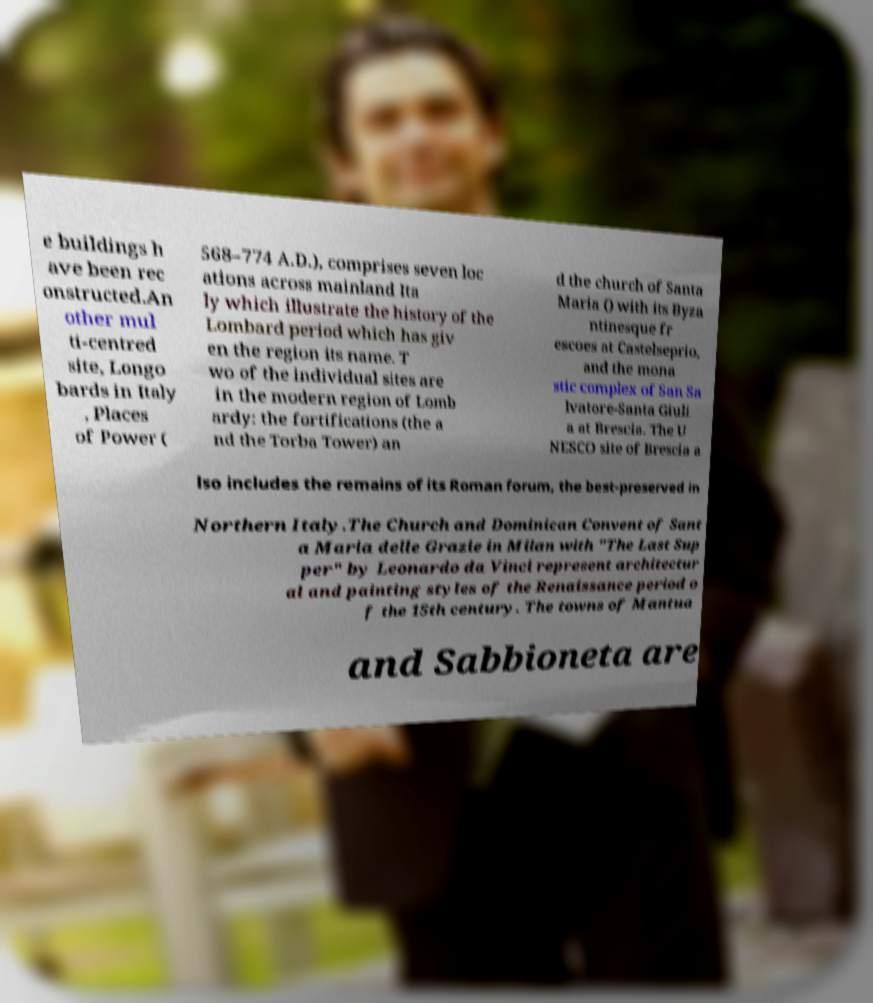Can you accurately transcribe the text from the provided image for me? e buildings h ave been rec onstructed.An other mul ti-centred site, Longo bards in Italy , Places of Power ( 568–774 A.D.), comprises seven loc ations across mainland Ita ly which illustrate the history of the Lombard period which has giv en the region its name. T wo of the individual sites are in the modern region of Lomb ardy: the fortifications (the a nd the Torba Tower) an d the church of Santa Maria () with its Byza ntinesque fr escoes at Castelseprio, and the mona stic complex of San Sa lvatore-Santa Giuli a at Brescia. The U NESCO site of Brescia a lso includes the remains of its Roman forum, the best-preserved in Northern Italy.The Church and Dominican Convent of Sant a Maria delle Grazie in Milan with "The Last Sup per" by Leonardo da Vinci represent architectur al and painting styles of the Renaissance period o f the 15th century. The towns of Mantua and Sabbioneta are 